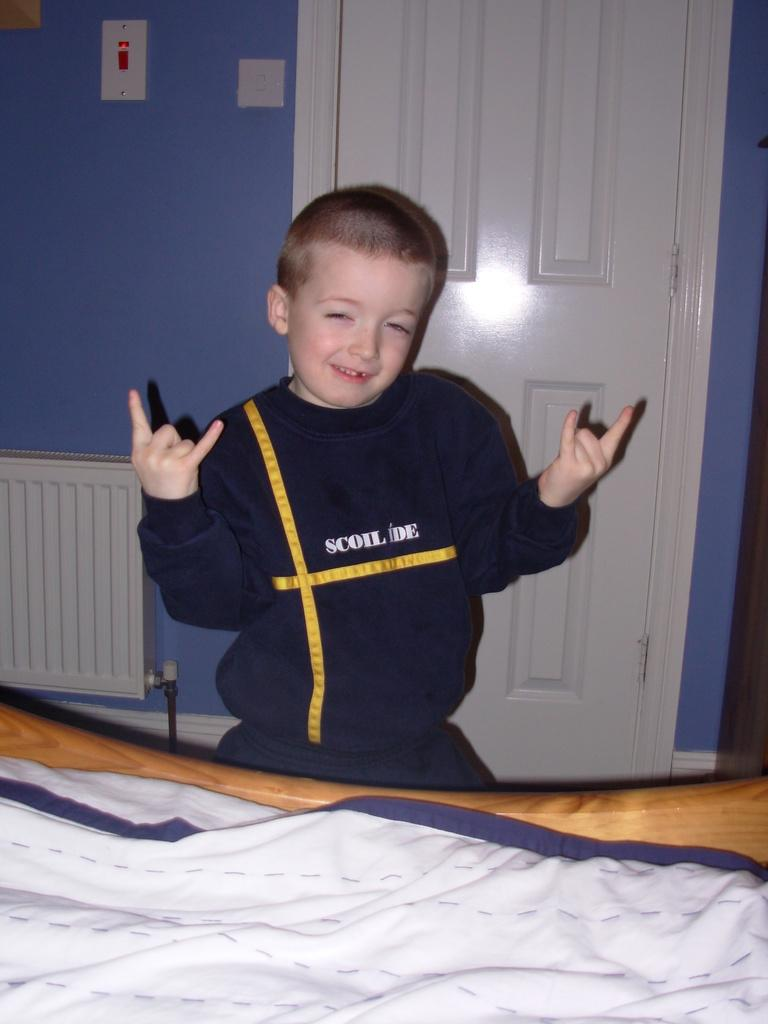<image>
Write a terse but informative summary of the picture. a young boy making two rock out signs with his hands, wearing a sweater that sais SCOIL IDE 